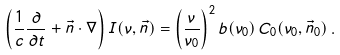Convert formula to latex. <formula><loc_0><loc_0><loc_500><loc_500>\left ( \frac { 1 } { c } \frac { \partial } { \partial t } + \vec { n } \cdot \nabla \right ) I ( \nu , \vec { n } ) = \left ( \frac { \nu } { \nu _ { 0 } } \right ) ^ { 2 } b ( \nu _ { 0 } ) \, C _ { 0 } ( \nu _ { 0 } , \vec { n } _ { 0 } ) \, .</formula> 